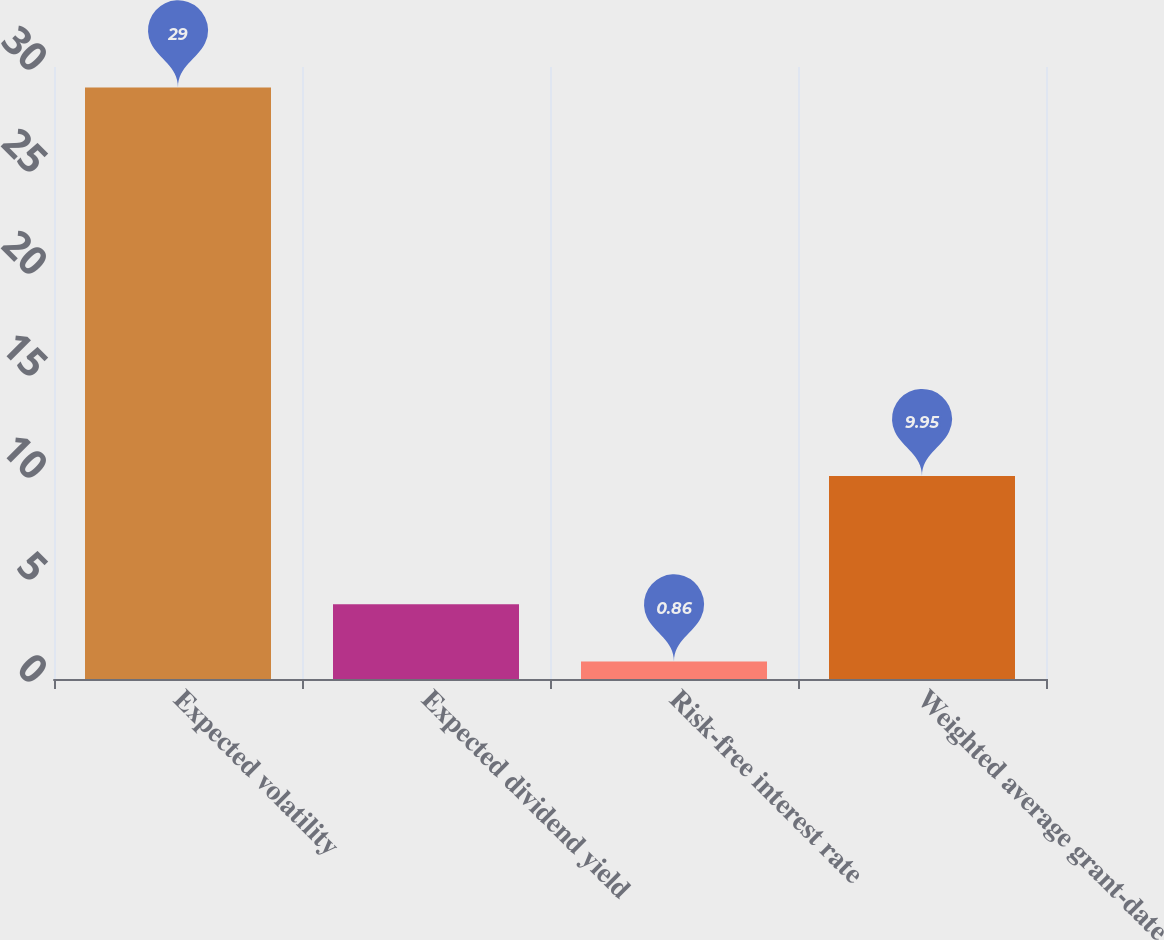<chart> <loc_0><loc_0><loc_500><loc_500><bar_chart><fcel>Expected volatility<fcel>Expected dividend yield<fcel>Risk-free interest rate<fcel>Weighted average grant-date<nl><fcel>29<fcel>3.67<fcel>0.86<fcel>9.95<nl></chart> 